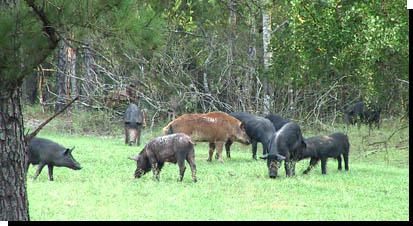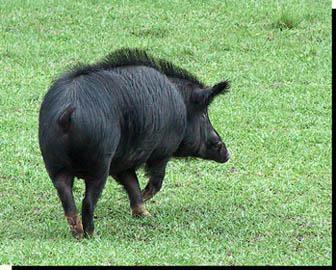The first image is the image on the left, the second image is the image on the right. Examine the images to the left and right. Is the description "Each image shows only one pig and in one of the images that pig is in the mud." accurate? Answer yes or no. No. The first image is the image on the left, the second image is the image on the right. Considering the images on both sides, is "In the image on the right there is one black wild boar outdoors." valid? Answer yes or no. Yes. 